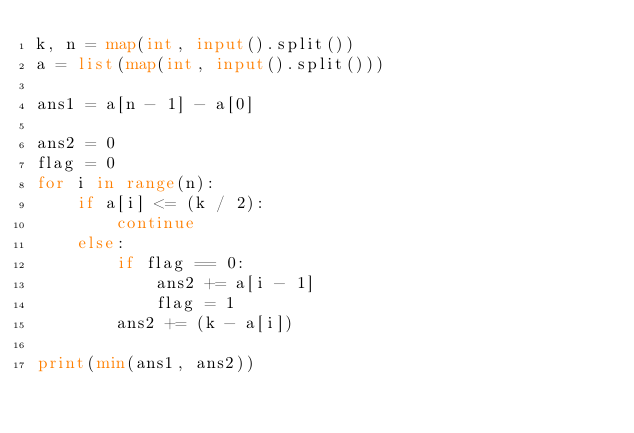<code> <loc_0><loc_0><loc_500><loc_500><_Python_>k, n = map(int, input().split())
a = list(map(int, input().split()))

ans1 = a[n - 1] - a[0]

ans2 = 0
flag = 0
for i in range(n):
    if a[i] <= (k / 2):
        continue
    else:
        if flag == 0:
            ans2 += a[i - 1]
            flag = 1
        ans2 += (k - a[i])

print(min(ans1, ans2))</code> 